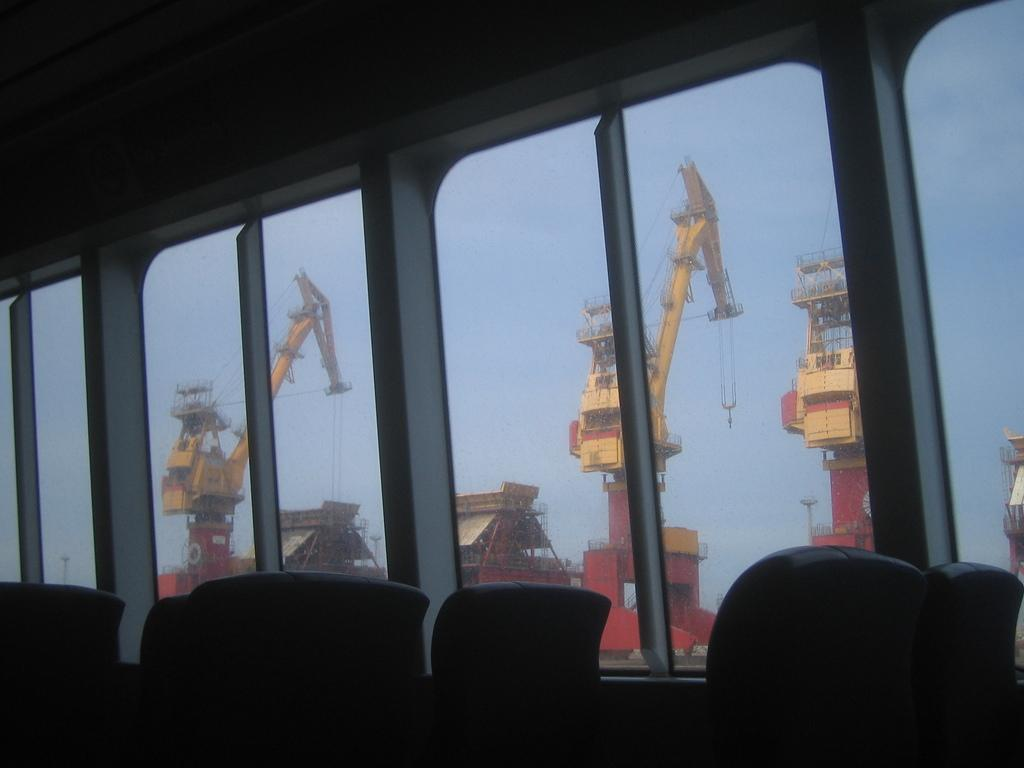What type of vehicle is shown in the image? There is a bus in the image. What can be found inside the bus? There are seats inside the bus in the image. What allows passengers to see the outside while inside the bus? There are windows visible in the image. What is visible in the background of the image? There are big cranes in the background of the image. What is visible at the top of the image? The sky is visible at the top of the image. What shape is the coal in the image? There is no coal present in the image. How many houses are visible in the image? There are no houses visible in the image. 